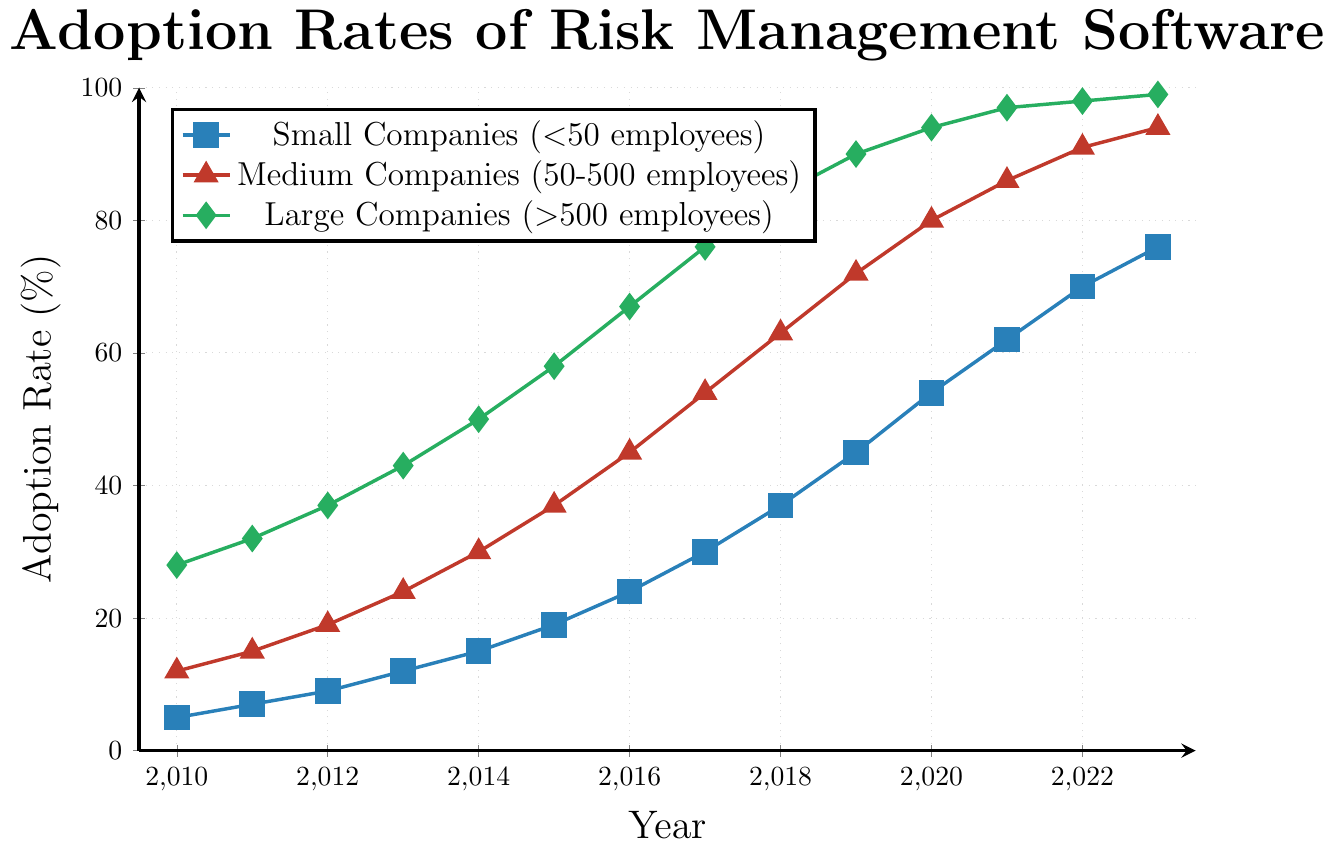How did the adoption rate for large companies change from 2010 to 2020? To find the change, subtract the adoption rate in 2010 from the rate in 2020 for large companies. In 2010, the rate was 28%, and in 2020, it was 94%. The change is 94% - 28% = 66%.
Answer: 66% In which year did medium companies' adoption rates reach 45%? Find the year on the x-axis corresponding to a 45% adoption rate for medium companies. This happens in 2016.
Answer: 2016 Compare the adoption rates of small and large companies in 2012. Identify the adoption rates in 2012 for both categories by looking at the y-axis values. Small companies had a rate of 9%, and large companies had a rate of 37%. Since 37% is greater than 9%, large companies had a higher adoption rate.
Answer: Large companies What is the difference in adoption rates between small and medium companies in 2017? Find the adoption rates for small and medium companies in 2017, which are 30% and 54%, respectively. Subtract the rate for small companies from the rate for medium companies: 54% - 30% = 24%.
Answer: 24% When did small companies first reach at least a 50% adoption rate? Check the y-axis to find the first year small companies exceeded 50%. This happens in 2020, when the rate is 54%.
Answer: 2020 What trend is observed in the adoption rates of large companies from 2010 to 2023? Observe the line corresponding to large companies, which steadily increases each year, showing a consistent upward trend from 28% in 2010 to 99% in 2023.
Answer: Steady increase Which color line represents medium companies' adoption rates? Look at the legend in the chart which shows the medium companies' adoption line using the red color.
Answer: Red If we average the adoption rates of small companies from 2018 to 2020, what is the result? The rates for small companies are 37% in 2018, 45% in 2019, and 54% in 2020. Sum these values (37 + 45 + 54 = 136) and divide by the number of years (3) to get the average rate: 136 / 3 ≈ 45.33%.
Answer: 45.33% 